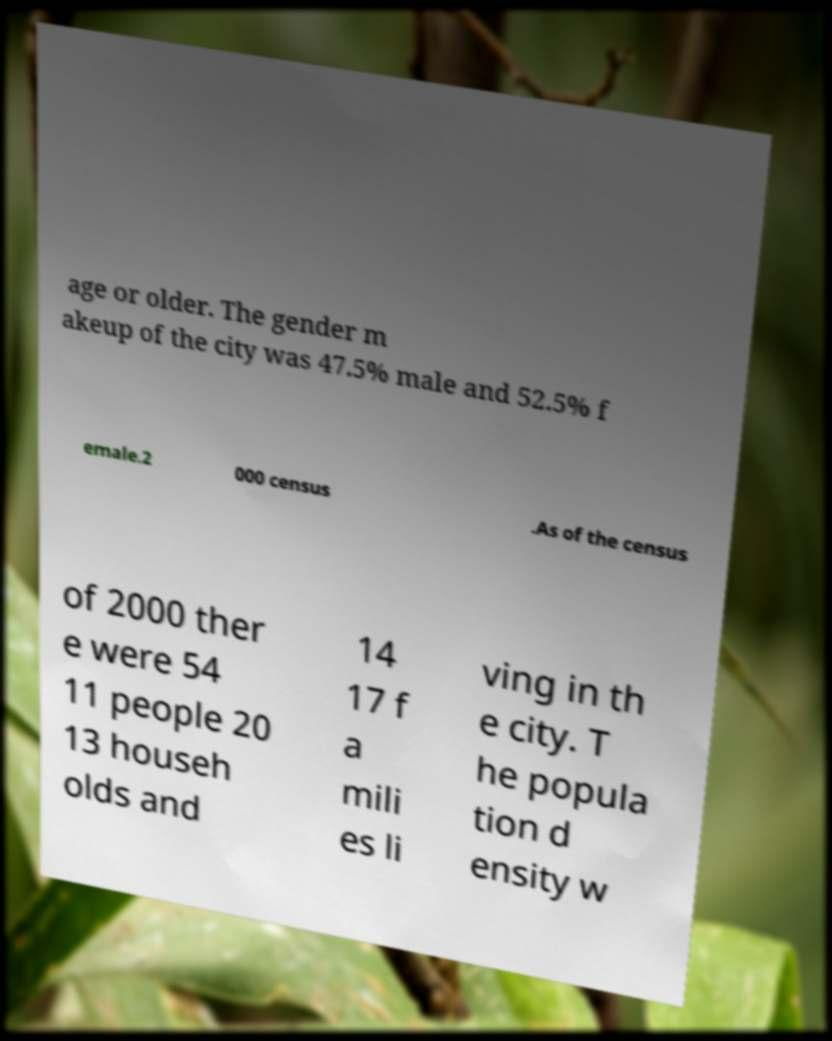For documentation purposes, I need the text within this image transcribed. Could you provide that? age or older. The gender m akeup of the city was 47.5% male and 52.5% f emale.2 000 census .As of the census of 2000 ther e were 54 11 people 20 13 househ olds and 14 17 f a mili es li ving in th e city. T he popula tion d ensity w 